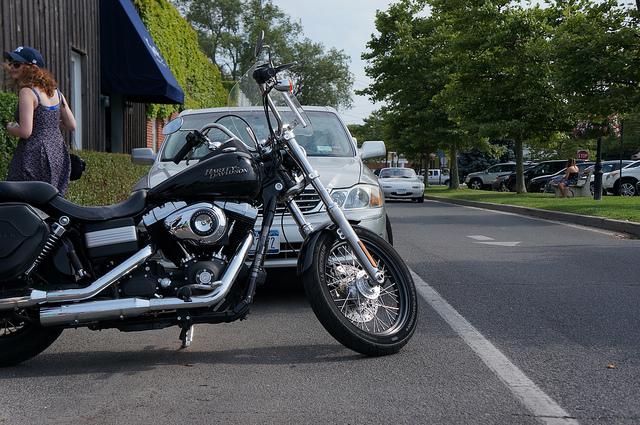Do you see women in the photo?
Quick response, please. Yes. How many motorcycles are parked on the road?
Concise answer only. 1. Does this motorcycle have a rider?
Quick response, please. No. What kind of hat is the girl wearing?
Give a very brief answer. Baseball cap. Is there a stop sign?
Give a very brief answer. No. 